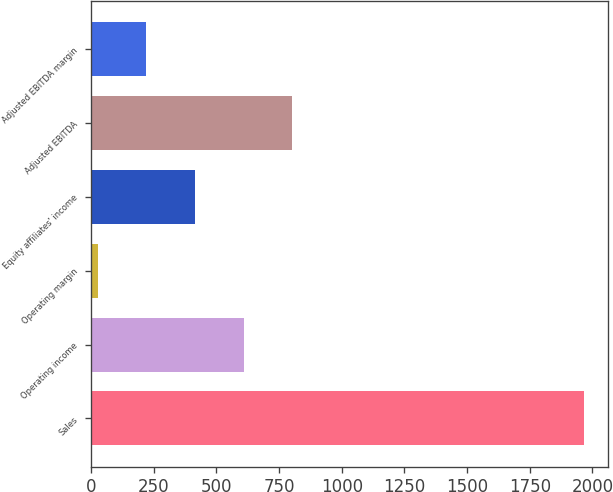Convert chart to OTSL. <chart><loc_0><loc_0><loc_500><loc_500><bar_chart><fcel>Sales<fcel>Operating income<fcel>Operating margin<fcel>Equity affiliates' income<fcel>Adjusted EBITDA<fcel>Adjusted EBITDA margin<nl><fcel>1964.7<fcel>608.38<fcel>27.1<fcel>414.62<fcel>802.14<fcel>220.86<nl></chart> 